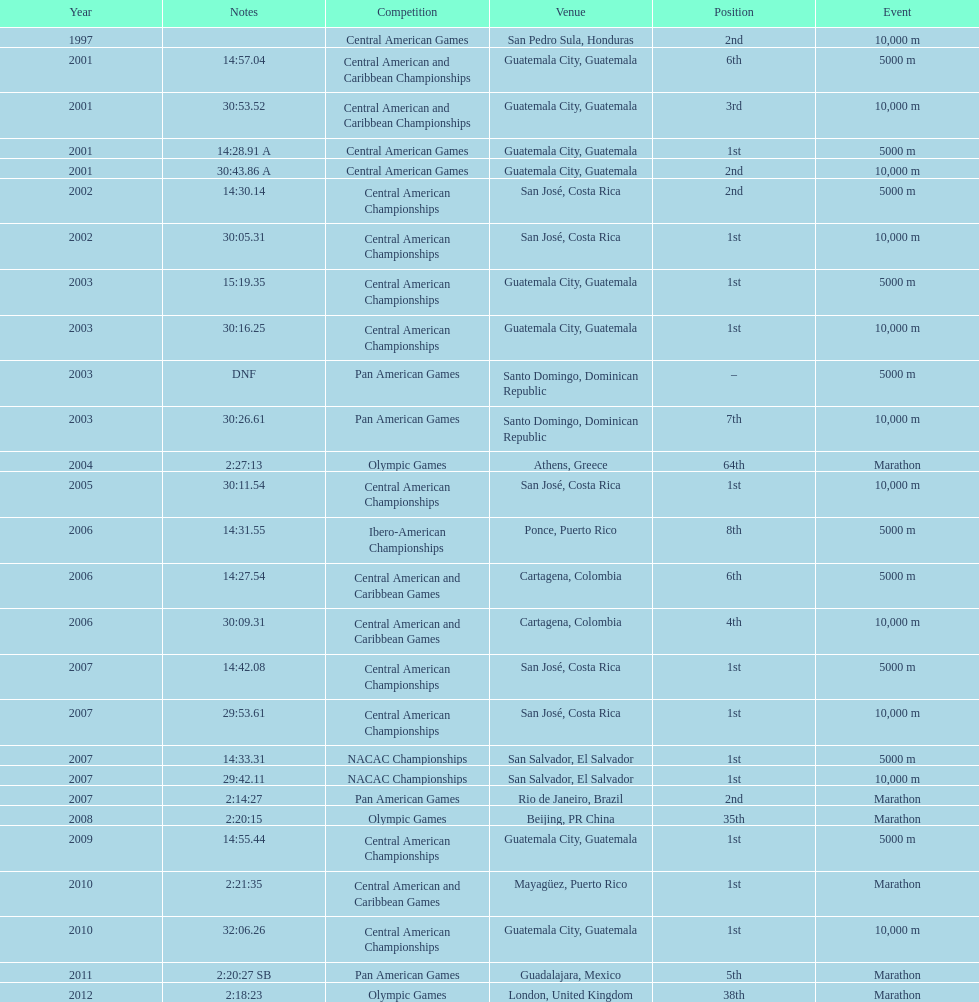Could you parse the entire table? {'header': ['Year', 'Notes', 'Competition', 'Venue', 'Position', 'Event'], 'rows': [['1997', '', 'Central American Games', 'San Pedro Sula, Honduras', '2nd', '10,000 m'], ['2001', '14:57.04', 'Central American and Caribbean Championships', 'Guatemala City, Guatemala', '6th', '5000 m'], ['2001', '30:53.52', 'Central American and Caribbean Championships', 'Guatemala City, Guatemala', '3rd', '10,000 m'], ['2001', '14:28.91 A', 'Central American Games', 'Guatemala City, Guatemala', '1st', '5000 m'], ['2001', '30:43.86 A', 'Central American Games', 'Guatemala City, Guatemala', '2nd', '10,000 m'], ['2002', '14:30.14', 'Central American Championships', 'San José, Costa Rica', '2nd', '5000 m'], ['2002', '30:05.31', 'Central American Championships', 'San José, Costa Rica', '1st', '10,000 m'], ['2003', '15:19.35', 'Central American Championships', 'Guatemala City, Guatemala', '1st', '5000 m'], ['2003', '30:16.25', 'Central American Championships', 'Guatemala City, Guatemala', '1st', '10,000 m'], ['2003', 'DNF', 'Pan American Games', 'Santo Domingo, Dominican Republic', '–', '5000 m'], ['2003', '30:26.61', 'Pan American Games', 'Santo Domingo, Dominican Republic', '7th', '10,000 m'], ['2004', '2:27:13', 'Olympic Games', 'Athens, Greece', '64th', 'Marathon'], ['2005', '30:11.54', 'Central American Championships', 'San José, Costa Rica', '1st', '10,000 m'], ['2006', '14:31.55', 'Ibero-American Championships', 'Ponce, Puerto Rico', '8th', '5000 m'], ['2006', '14:27.54', 'Central American and Caribbean Games', 'Cartagena, Colombia', '6th', '5000 m'], ['2006', '30:09.31', 'Central American and Caribbean Games', 'Cartagena, Colombia', '4th', '10,000 m'], ['2007', '14:42.08', 'Central American Championships', 'San José, Costa Rica', '1st', '5000 m'], ['2007', '29:53.61', 'Central American Championships', 'San José, Costa Rica', '1st', '10,000 m'], ['2007', '14:33.31', 'NACAC Championships', 'San Salvador, El Salvador', '1st', '5000 m'], ['2007', '29:42.11', 'NACAC Championships', 'San Salvador, El Salvador', '1st', '10,000 m'], ['2007', '2:14:27', 'Pan American Games', 'Rio de Janeiro, Brazil', '2nd', 'Marathon'], ['2008', '2:20:15', 'Olympic Games', 'Beijing, PR China', '35th', 'Marathon'], ['2009', '14:55.44', 'Central American Championships', 'Guatemala City, Guatemala', '1st', '5000 m'], ['2010', '2:21:35', 'Central American and Caribbean Games', 'Mayagüez, Puerto Rico', '1st', 'Marathon'], ['2010', '32:06.26', 'Central American Championships', 'Guatemala City, Guatemala', '1st', '10,000 m'], ['2011', '2:20:27 SB', 'Pan American Games', 'Guadalajara, Mexico', '5th', 'Marathon'], ['2012', '2:18:23', 'Olympic Games', 'London, United Kingdom', '38th', 'Marathon']]} How many times has the position of 1st been achieved? 12. 